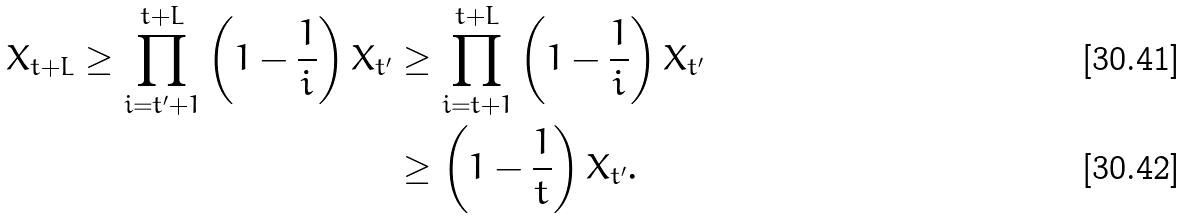<formula> <loc_0><loc_0><loc_500><loc_500>X _ { t + L } \geq \prod _ { i = t ^ { \prime } + 1 } ^ { t + L } \left ( 1 - \frac { 1 } { i } \right ) X _ { t ^ { \prime } } & \geq \prod _ { i = t + 1 } ^ { t + L } \left ( 1 - \frac { 1 } { i } \right ) X _ { t ^ { \prime } } \\ & \geq \left ( 1 - \frac { 1 } { t } \right ) X _ { t ^ { \prime } } .</formula> 